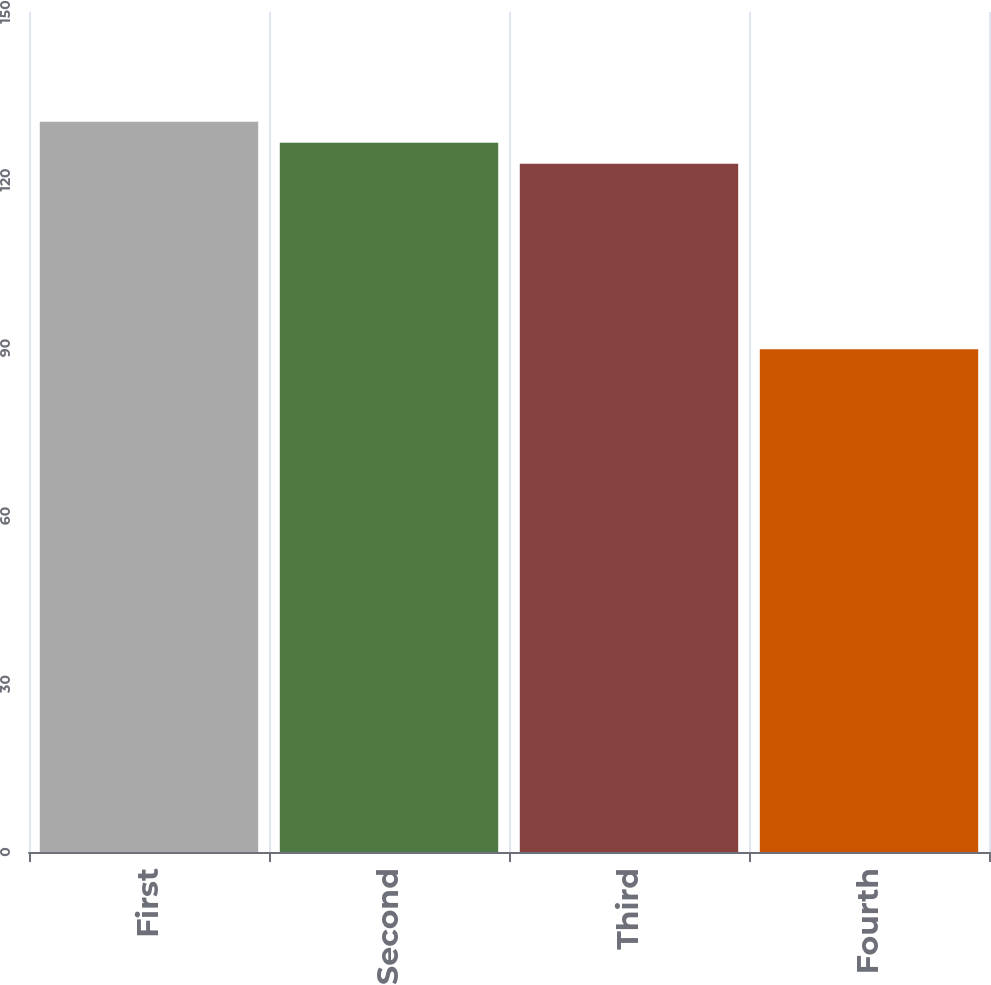Convert chart to OTSL. <chart><loc_0><loc_0><loc_500><loc_500><bar_chart><fcel>First<fcel>Second<fcel>Third<fcel>Fourth<nl><fcel>130.42<fcel>126.65<fcel>122.88<fcel>89.76<nl></chart> 